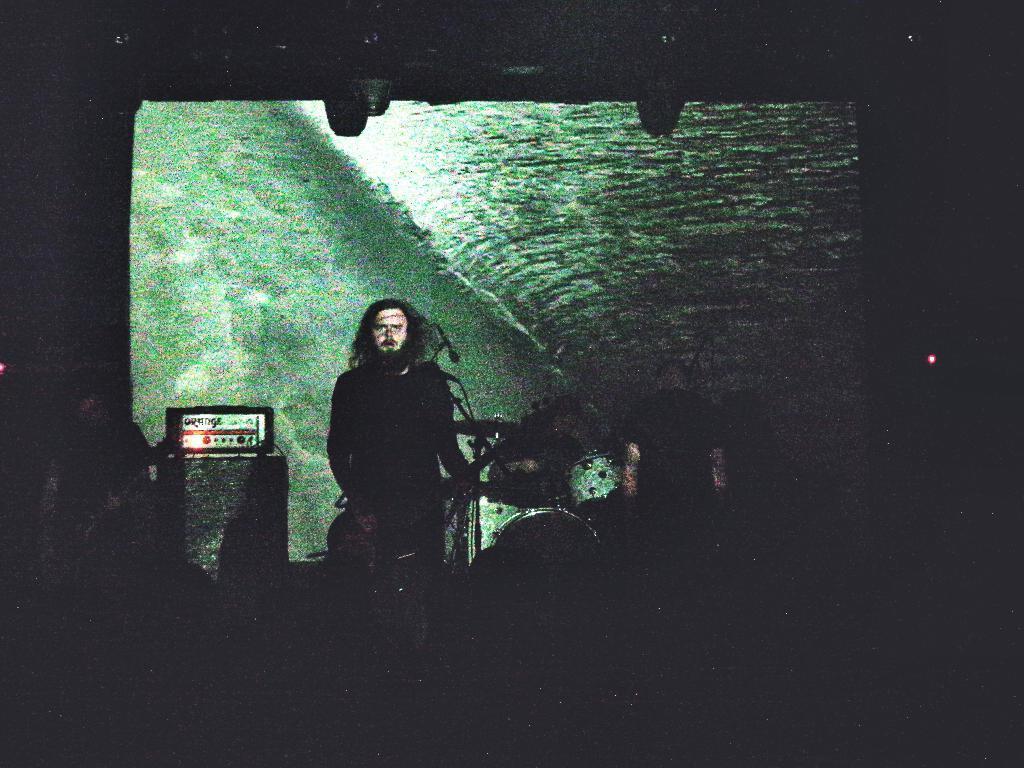In one or two sentences, can you explain what this image depicts? In this picture there is a person standing and playing guitar and there are some objects behind him. 